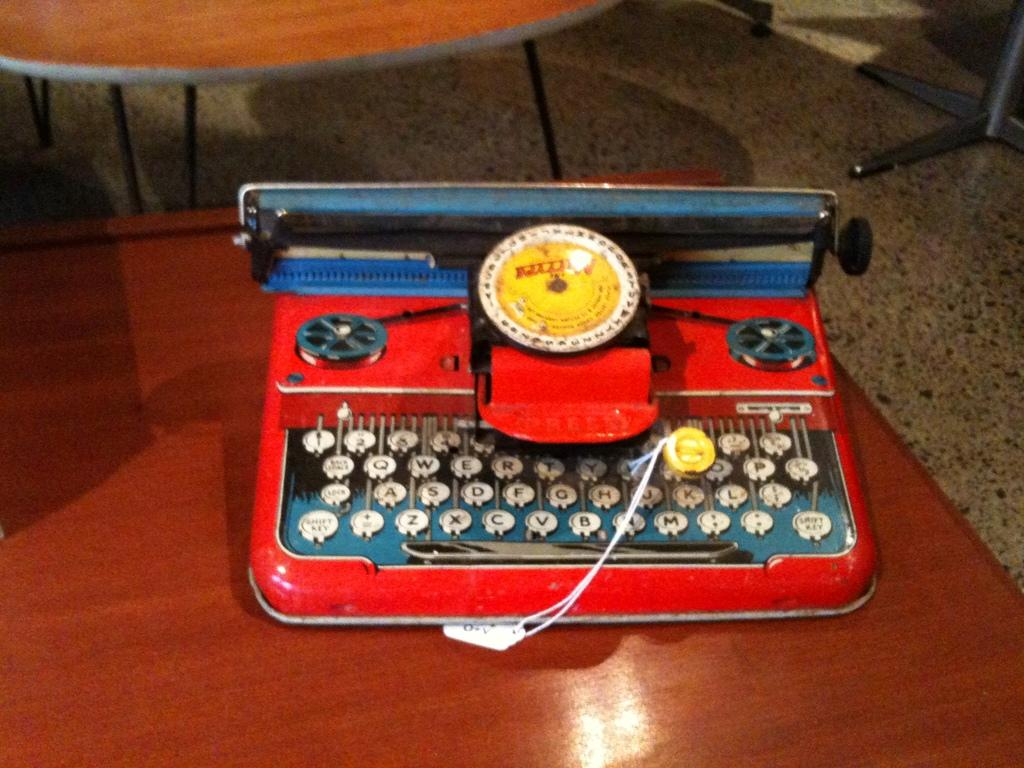<image>
Present a compact description of the photo's key features. A red device has a keyboard with keys reading z, x and c. 